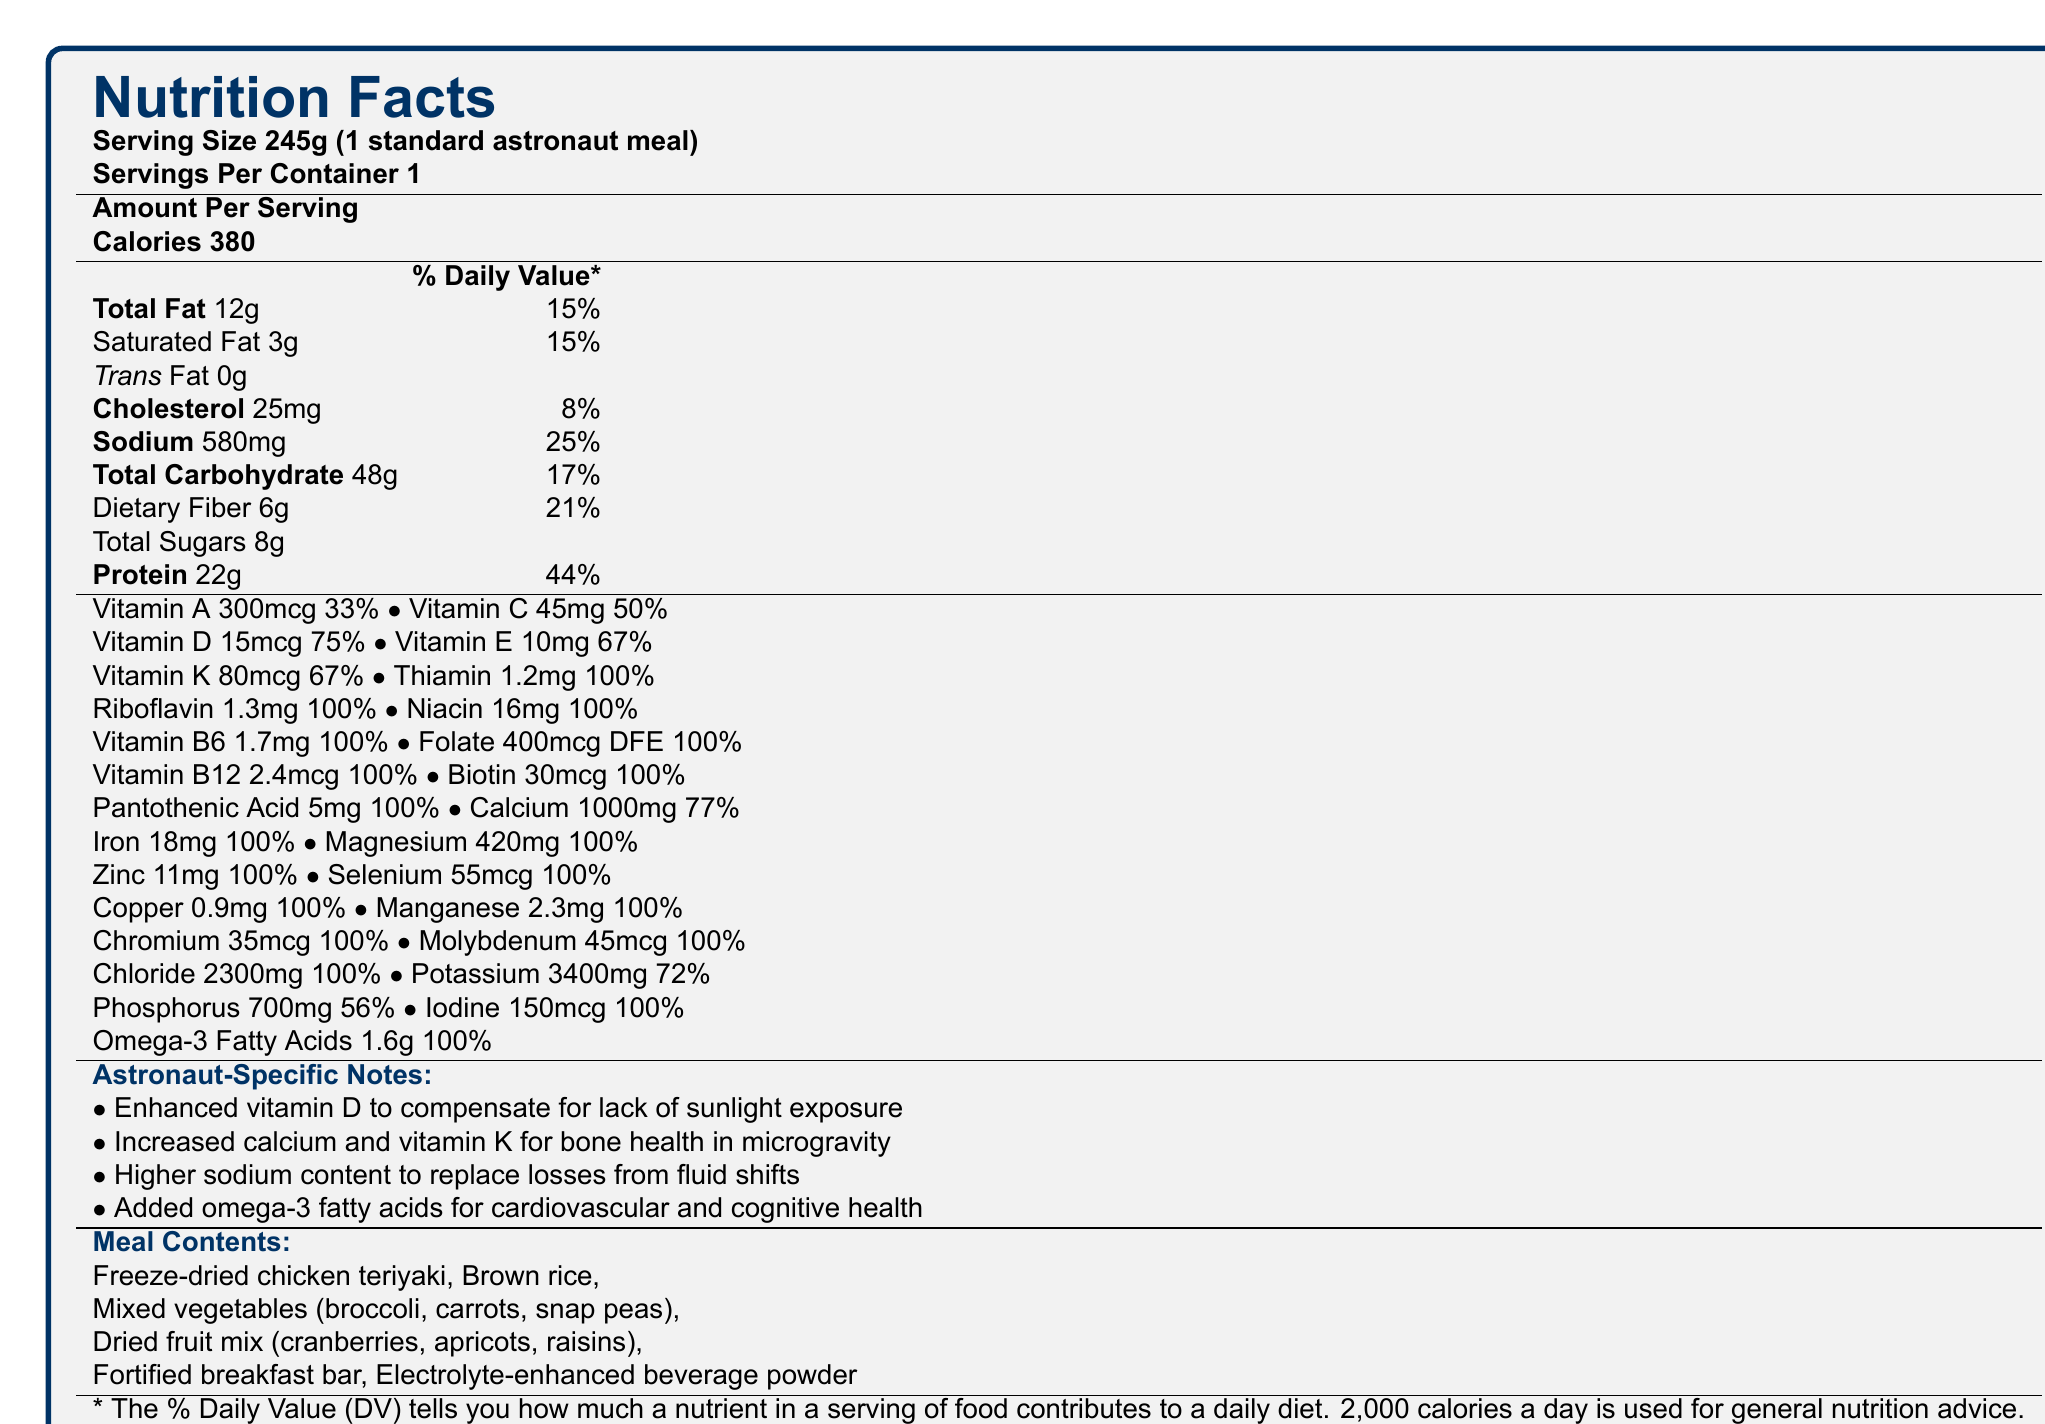what is the serving size for the astronaut meal? The document states that the serving size is 245g (1 standard astronaut meal).
Answer: 245g How many calories are in one serving of the astronaut meal? The document specifies that one serving of the astronaut meal contains 380 calories.
Answer: 380 calories what is the amount of dietary fiber per serving, and what percentage of the daily value does it represent? The document lists the dietary fiber amount as 6g, which represents 21% of the daily value.
Answer: 6g, 21% Which vitamin has the highest percentage of the daily value in the astronaut meal? A. Vitamin C B. Vitamin D C. Thiamin D. Calcium The document indicates that Thiamin has a daily value of 100%, which is the highest among the options listed.
Answer: C. Thiamin How much added sugar is in the astronaut meal? The document does not mention added sugars separately, indicating that there are no added sugars.
Answer: 0g Which statement accurately describes the sodium content in the astronaut meal? The document lists the sodium content as 580mg, representing 25% of the daily value. The other options are incorrect.
Answer: B True or False: The astronaut meal contains trans fat. The document specifies that the meal contains 0g of trans fat.
Answer: False What are two key reasons for higher calcium and vitamin K in the astronaut meal? The document notes that increased calcium and vitamin K are included to promote bone health during microgravity conditions.
Answer: Bone health in microgravity Summarize the main objective of the astronaut meal plan. This summary covers the primary purpose and specific adjustments mentioned in the document.
Answer: The astronaut meal plan aims to provide a nutritionally balanced meal containing essential vitamins and minerals to maintain optimal health during extended zero-gravity exposure. To address specific challenges of space, the meal includes enhanced vitamin D, calcium, vitamin K, and omega-3 fatty acids. What is the total fat content in the astronaut meal? The document specifies that the total fat content in the astronaut meal is 12g.
Answer: 12g Which nutrient is included in the astronaut meal specifically for cardiovascular and cognitive health? The document mentions that omega-3 fatty acids are added for cardiovascular and cognitive health.
Answer: Omega-3 fatty acids What type of meal contents are included in the astronaut meal? The document lists these items as the contents of the astronaut meal.
Answer: Freeze-dried chicken teriyaki, brown rice, mixed vegetables, dried fruit mix, fortified breakfast bar, electrolyte-enhanced beverage powder What is the reason for enhanced vitamin D in the astronaut meal? The document states that vitamin D is enhanced to compensate for the lack of sunlight exposure in space.
Answer: To compensate for lack of sunlight exposure How much protein does the astronaut meal provide, and what percentage of the daily value does this represent? The document specifies that the meal provides 22g of protein, which represents 44% of the daily value.
Answer: 22g, 44% What information is missing regarding the exact source of ingredients in the astronaut meal? The document does not provide specific information about the source of the ingredients included in the meal.
Answer: Cannot be determined 